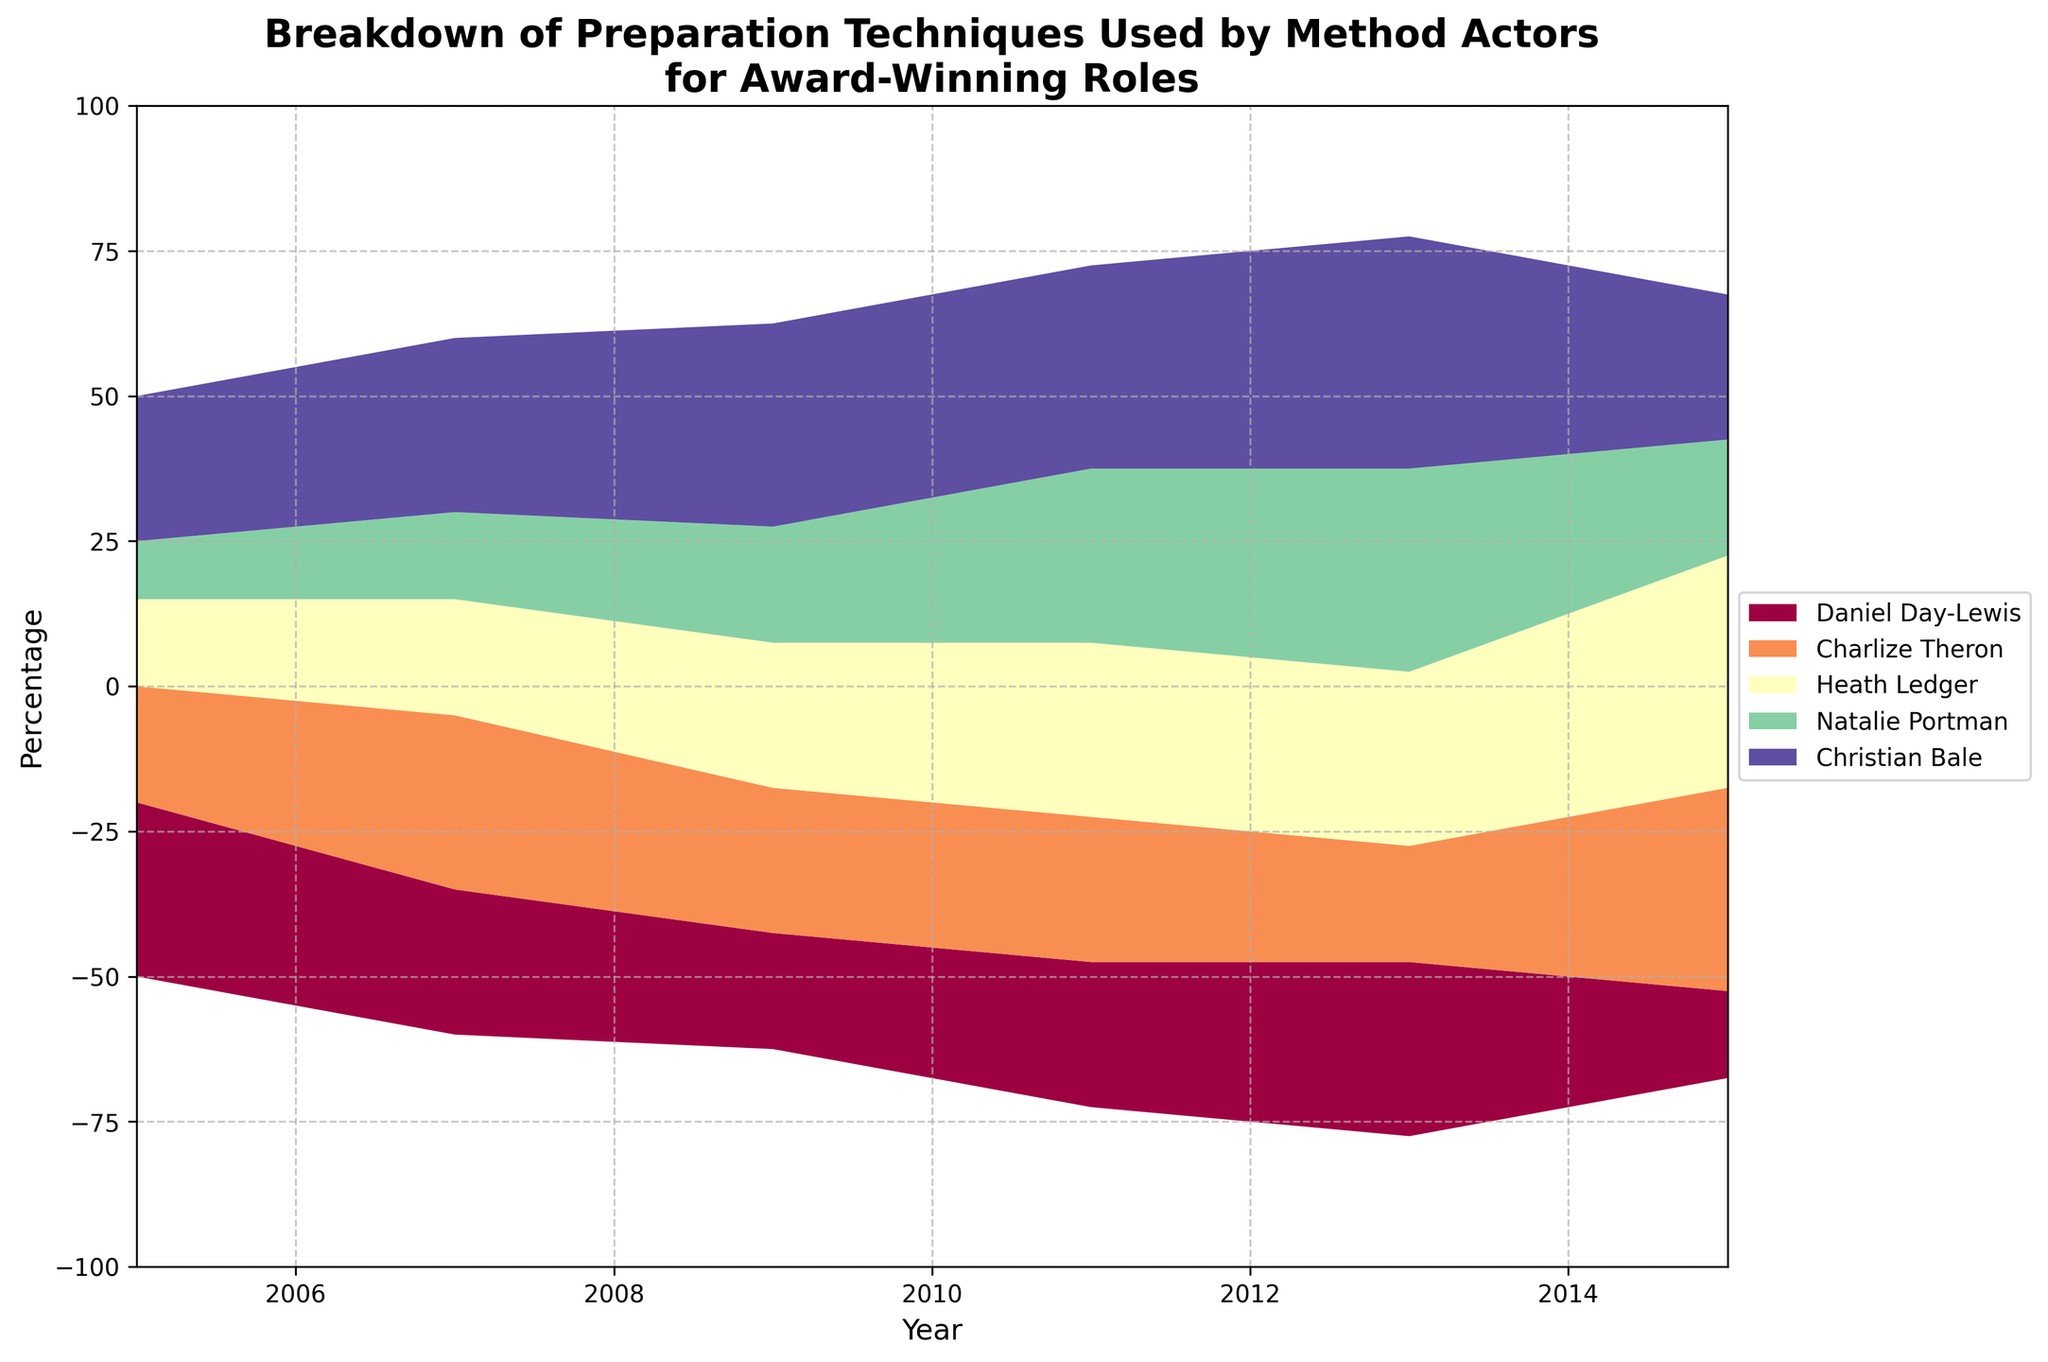What's the title of the figure? The title is located at the top of the figure and explains the theme of the visualization. It reads "Breakdown of Preparation Techniques Used by Method Actors for Award-Winning Roles".
Answer: Breakdown of Preparation Techniques Used by Method Actors for Award-Winning Roles Which year's data has the highest value for Heath Ledger? To find this, look at the stream graph and identify which segment representing Heath Ledger (typically with distinct colors) reaches its peak. Examine the values across the years.
Answer: 2015 How many different categories of preparation techniques are shown in the graph? The legend on the right side of the graph lists the different categories. Each category represents a unique preparation technique.
Answer: 5 In which year did Natalie Portman use the 'Magic If' technique the most? Look at the distinct section denoted by Natalie Portman for the 'Magic If' technique and check the height of this segment in the corresponding year in the stream graph.
Answer: 2013 Which actor shows the most variety in the techniques used over the years? To determine this, observe the range and variation of segments for each actor over the years. The actor who uses different techniques more evenly or changes techniques often represents the most variety.
Answer: Christian Bale Between 2007 and 2009, which actor increased their use of the Substitution Technique the most? Look at the segments for Substitution Technique in 2007 and 2009 for each actor. Compare the height differences to find the one with the biggest increase.
Answer: Heath Ledger Which preparation technique reached its highest peak in 2015? Identify the tallest segment in 2015 on the stream graph and note its associated category.
Answer: Animal Work How does the use of the 'Sense Memory' technique in 2007 compare to 'Emotional Recall' in 2005? Compare the height of the 'Sense Memory' segment in 2007 with the 'Emotional Recall' segment in 2005 for a direct comparison.
Answer: Sense Memory in 2007 is higher Summarize how Christian Bale's technique usage evolved from 2005 to 2015? Observe the stream representing Christian Bale’s sections over the years. Note the changes in the height and types of techniques used over time. Explain how his preparation methods have shifted annually.
Answer: Shifts from high 'Emotional Recall' in 2005 to more balanced methods, peaking in 'Magic If' and 'Given Circumstances' by 2015 Across all years, which actor predominantly used physical preparation techniques like 'Animal Work'? Look for the actor whose segments for 'Animal Work' are consistently taller across all years. This actor would have predominantly used physical preparation techniques.
Answer: Charlize Theron 